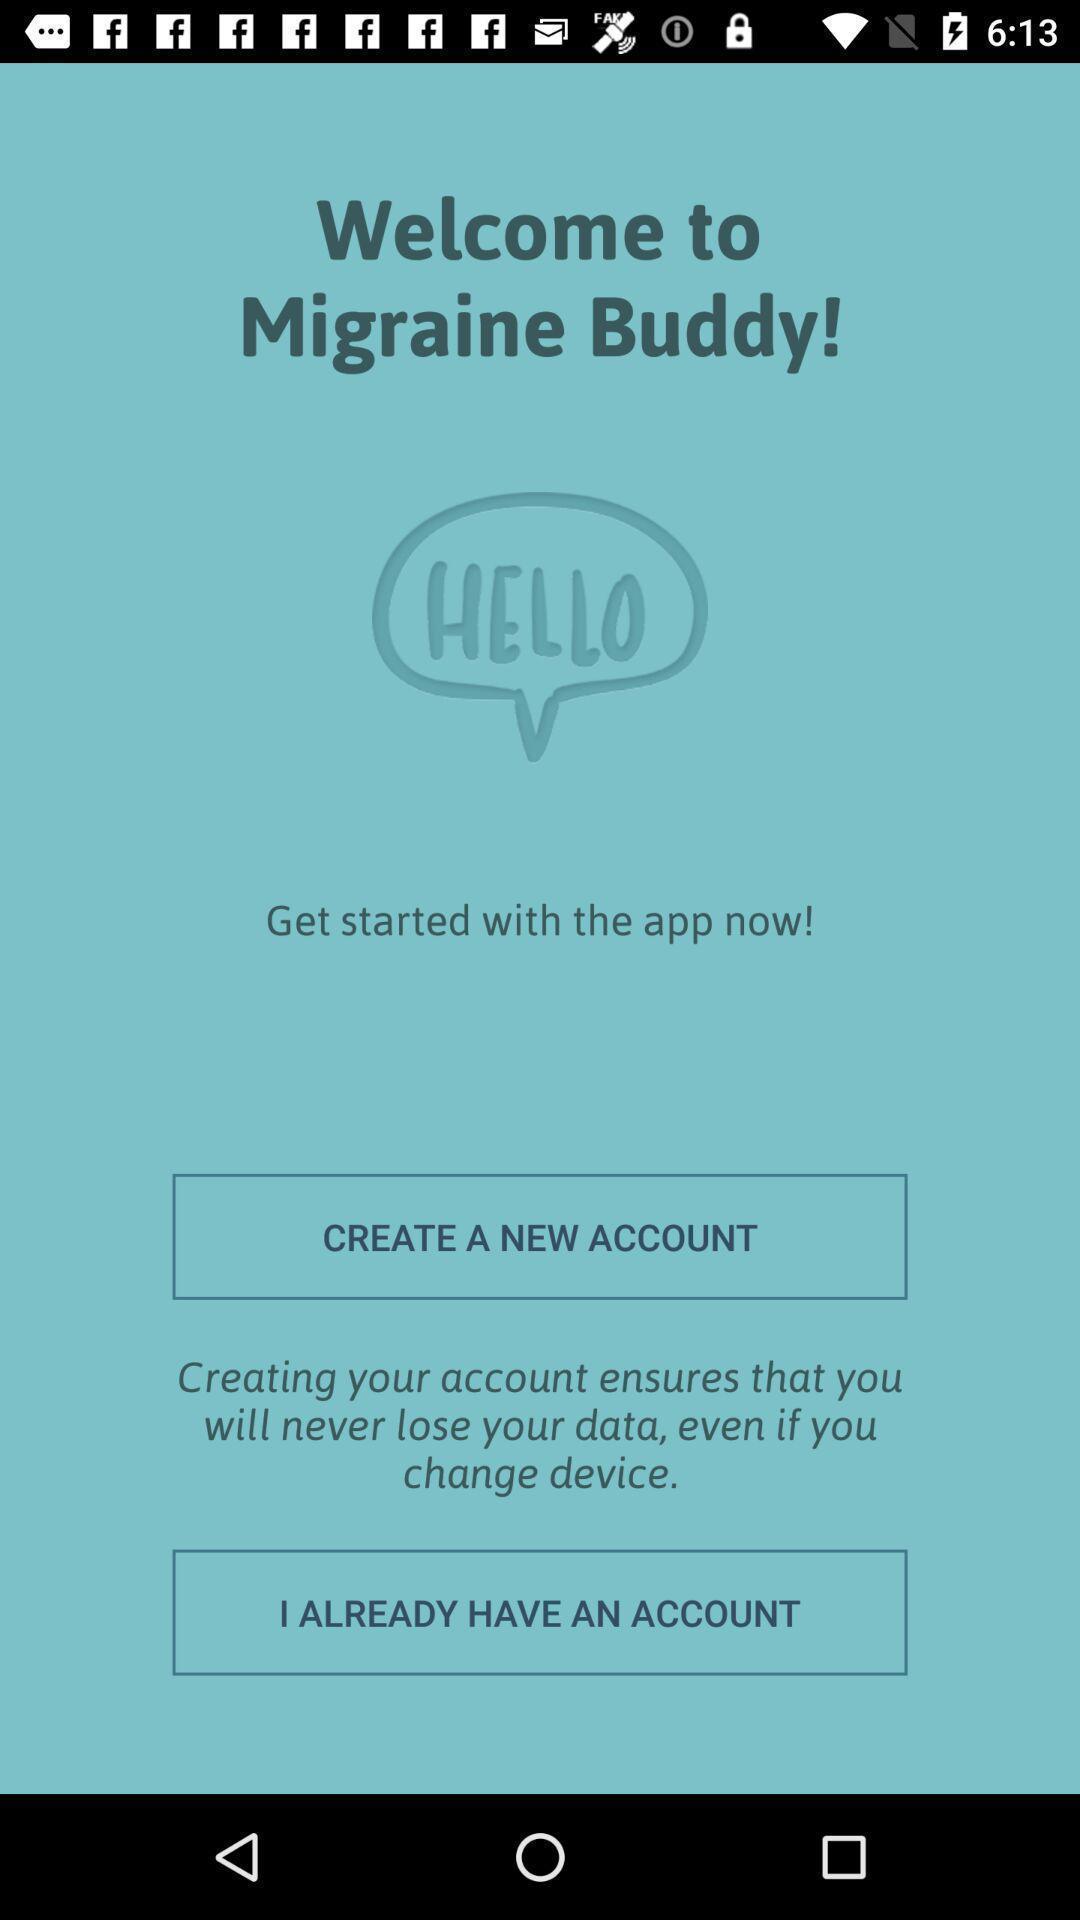Tell me about the visual elements in this screen capture. Welcome page. 